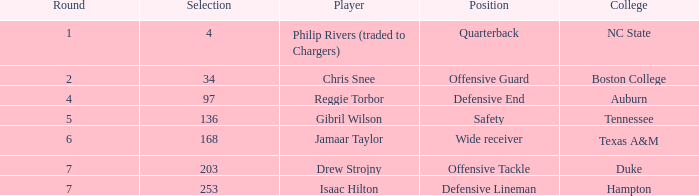Which Selection has a Player of jamaar taylor, and a Round larger than 6? None. 